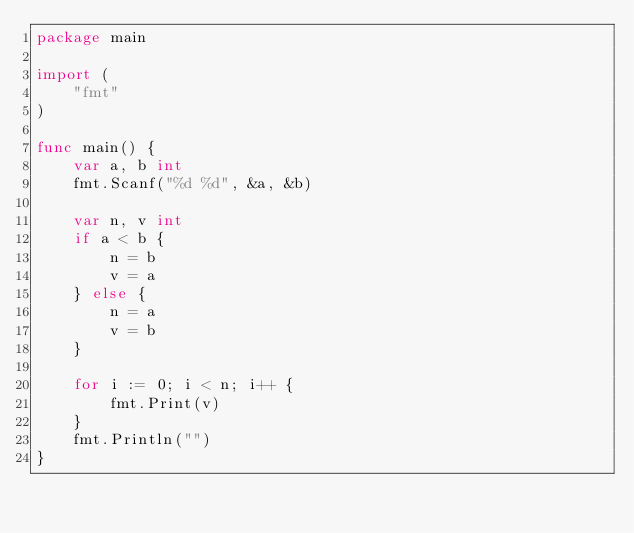Convert code to text. <code><loc_0><loc_0><loc_500><loc_500><_Go_>package main

import (
	"fmt"
)

func main() {
	var a, b int
	fmt.Scanf("%d %d", &a, &b)

	var n, v int
	if a < b {
		n = b
		v = a
	} else {
		n = a
		v = b
	}

	for i := 0; i < n; i++ {
		fmt.Print(v)
	}
	fmt.Println("")
}
</code> 